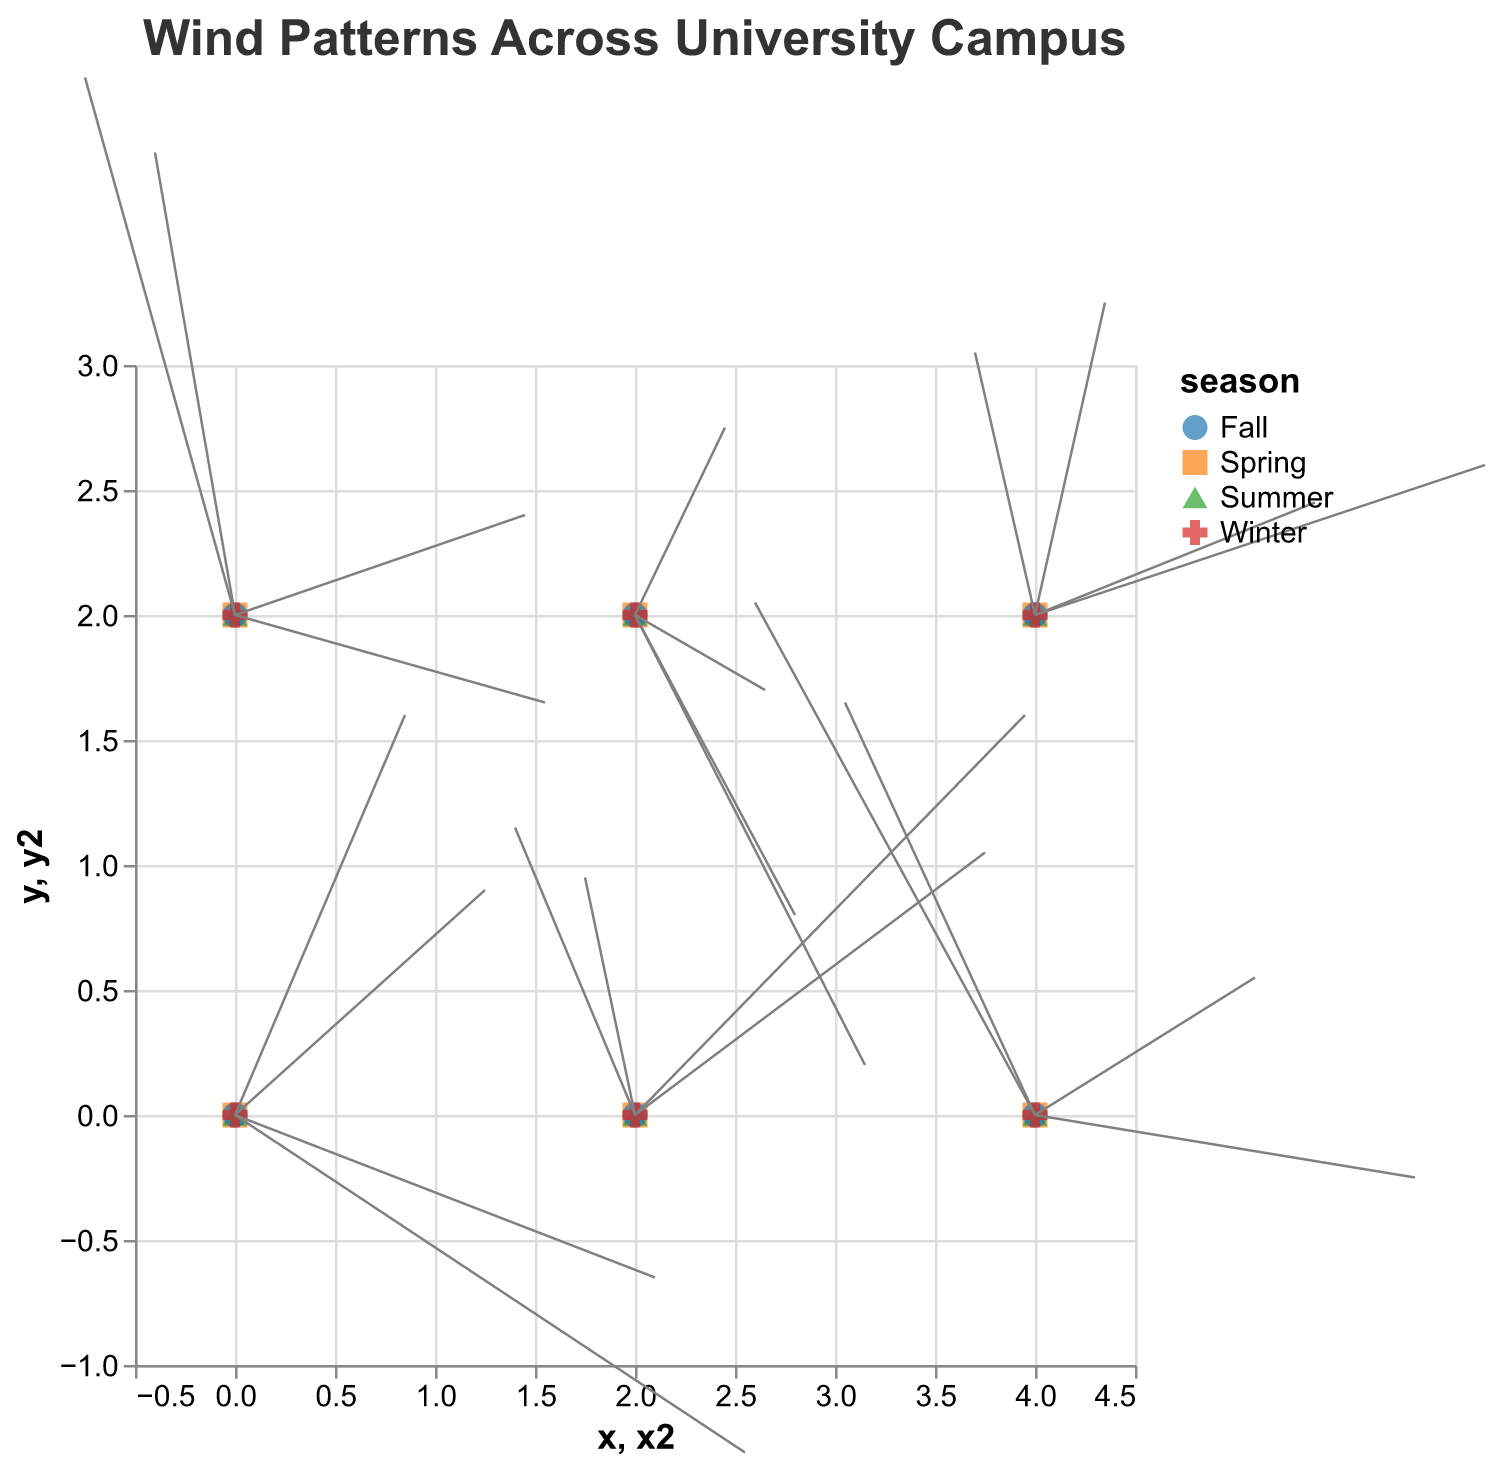What is the title of the figure? The title is found at the top of the figure, usually indicating what the chart is about. In this case, it is clearly labeled.
Answer: Wind Patterns Across University Campus How many seasons are represented in the figure? The figure uses different colors and shapes for different seasons, as indicated by the legend. The options in the season selector also show four choices.
Answer: Four Which season shows the strongest wind velocity at the point (0,0)? To determine the strongest wind velocity, look at the length of the arrows at the coordinate (0,0) for each season. The velocity is represented proportionally to the length of the arrows. The longest arrow length represents the highest wind velocity.
Answer: Winter What are the coordinates of the data points? The coordinates are indicated by the 'x' and 'y' axes. Examining the axis scales, data points are at (0,0), (0,2), (2,0), (2,2), (4,0), and (4,2).
Answer: (0,0), (0,2), (2,0), (2,2), (4,0), (4,2) What is the average u-component of the wind in the Summer across all points? To find this, sum the u-values for the Summer data points and divide by the number of points. The values are 1.7, 2.9, -0.5, 1.3, 2.2, and 0.7. Sum = 1.7 + 2.9 - 0.5 + 1.3 + 2.2 + 0.7 = 8.3. There are 6 data points, so the average u-component is 8.3/6.
Answer: 1.38 In which season does the wind have the highest combined velocity at the point (2,0)? Velocity can be calculated using the vector magnitude formula √(u² + v²). We calculate for each season:
- Spring: u=-1.2, v=2.3 -> √((-1.2)² + (2.3)²) = 2.6
- Summer: u=-0.5, v=1.9 -> √((-0.5)² + (1.9)²) = 1.96
- Fall: u=3.5, v=2.1 -> √((3.5)² + (2.1)²) = 4.06
- Winter: u=3.9, v=3.2 -> √((3.9)² + (3.2)²) = 5.05
Winter has the highest combined velocity.
Answer: Winter What direction is the wind blowing from at the coordinate (4,0) in Fall? The direction can be inferred by the u and v components. In Fall at (4,0), u is -1.9 (towards left/west) and v is 3.3 (upward/north).
Answer: Northwest Which season has the highest variability in wind direction at coordinate (0,2)? Variability in direction can be observed from how much the vectors change direction across seasons. For (0,2):
- Spring: u=3.1, v=-0.7 -> Angle = atan(-0.7/3.1)
- Summer: u=2.9, v=0.8 -> Angle = atan(0.8/2.9)
- Fall: u=-0.8, v=3.7 -> Angle = atan(3.7/-0.8)
- Winter: u=-1.5, v=4.3 -> Angle = atan(4.3/-1.5)
The angles vary significantly, showing high direction variability.
Answer: Winter 